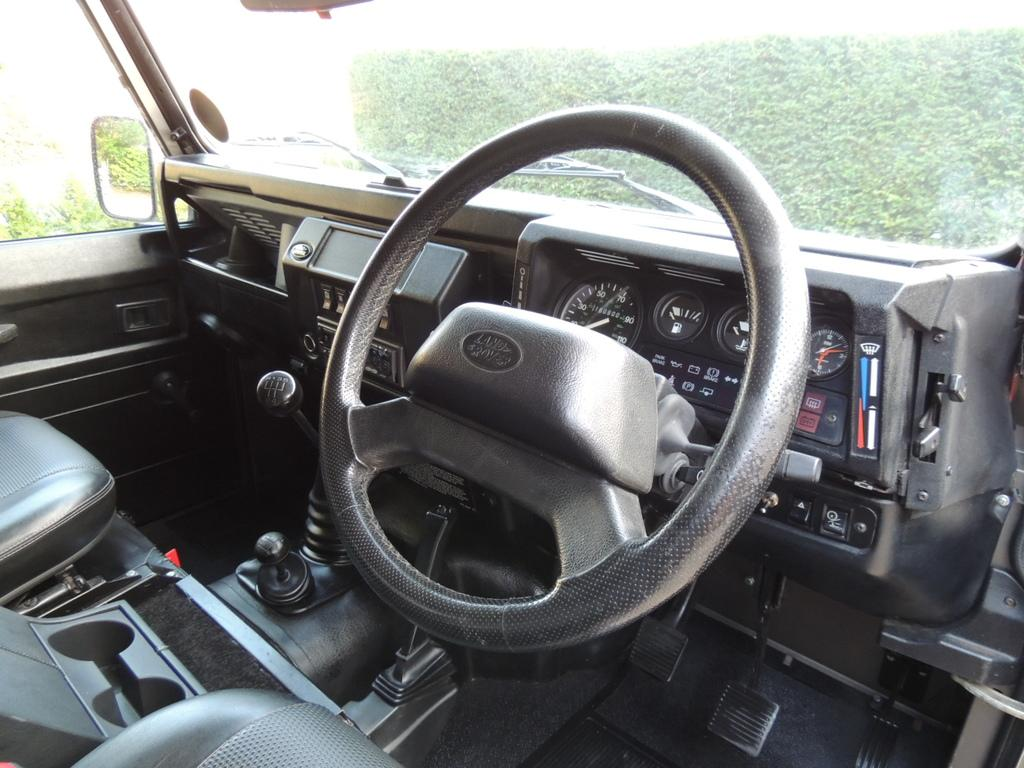What type of location is the image taken in? The image is inside a vehicle. What can be found inside the vehicle? There are seats, a steering wheel, gears, wipers, a mirror, and meters inside the vehicle. What is the purpose of the mirror in the vehicle? The mirror is likely used for the driver to see behind them while driving. What color wall is visible through the glass in the image? A green color wall is visible through the glass. Can you see any notes being written on the wall in the image? There are no notes or writing visible on the wall in the image. Is there anyone blowing bubbles in the vehicle in the image? There is no one blowing bubbles in the vehicle in the image. 